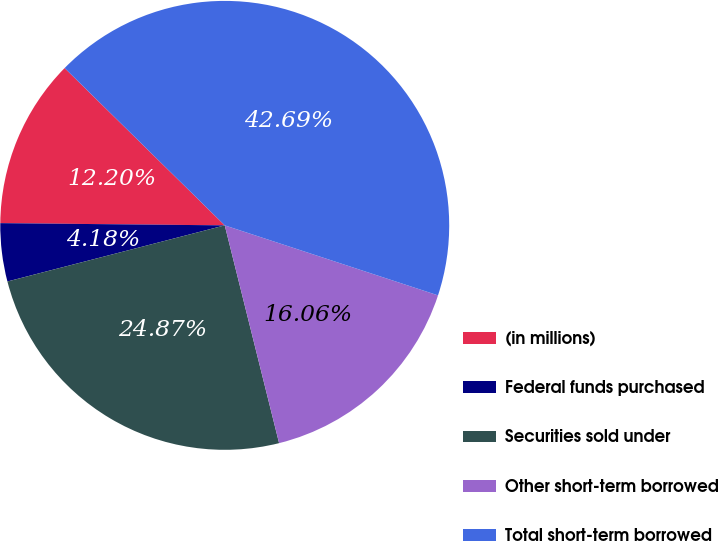<chart> <loc_0><loc_0><loc_500><loc_500><pie_chart><fcel>(in millions)<fcel>Federal funds purchased<fcel>Securities sold under<fcel>Other short-term borrowed<fcel>Total short-term borrowed<nl><fcel>12.2%<fcel>4.18%<fcel>24.87%<fcel>16.06%<fcel>42.69%<nl></chart> 